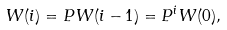<formula> <loc_0><loc_0><loc_500><loc_500>W ( i ) = P W ( i - 1 ) = P ^ { i } W ( 0 ) ,</formula> 